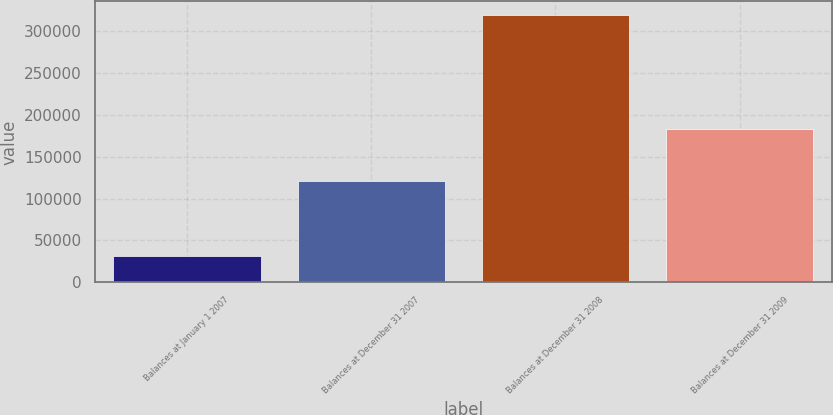<chart> <loc_0><loc_0><loc_500><loc_500><bar_chart><fcel>Balances at January 1 2007<fcel>Balances at December 31 2007<fcel>Balances at December 31 2008<fcel>Balances at December 31 2009<nl><fcel>30802<fcel>120955<fcel>319936<fcel>182733<nl></chart> 